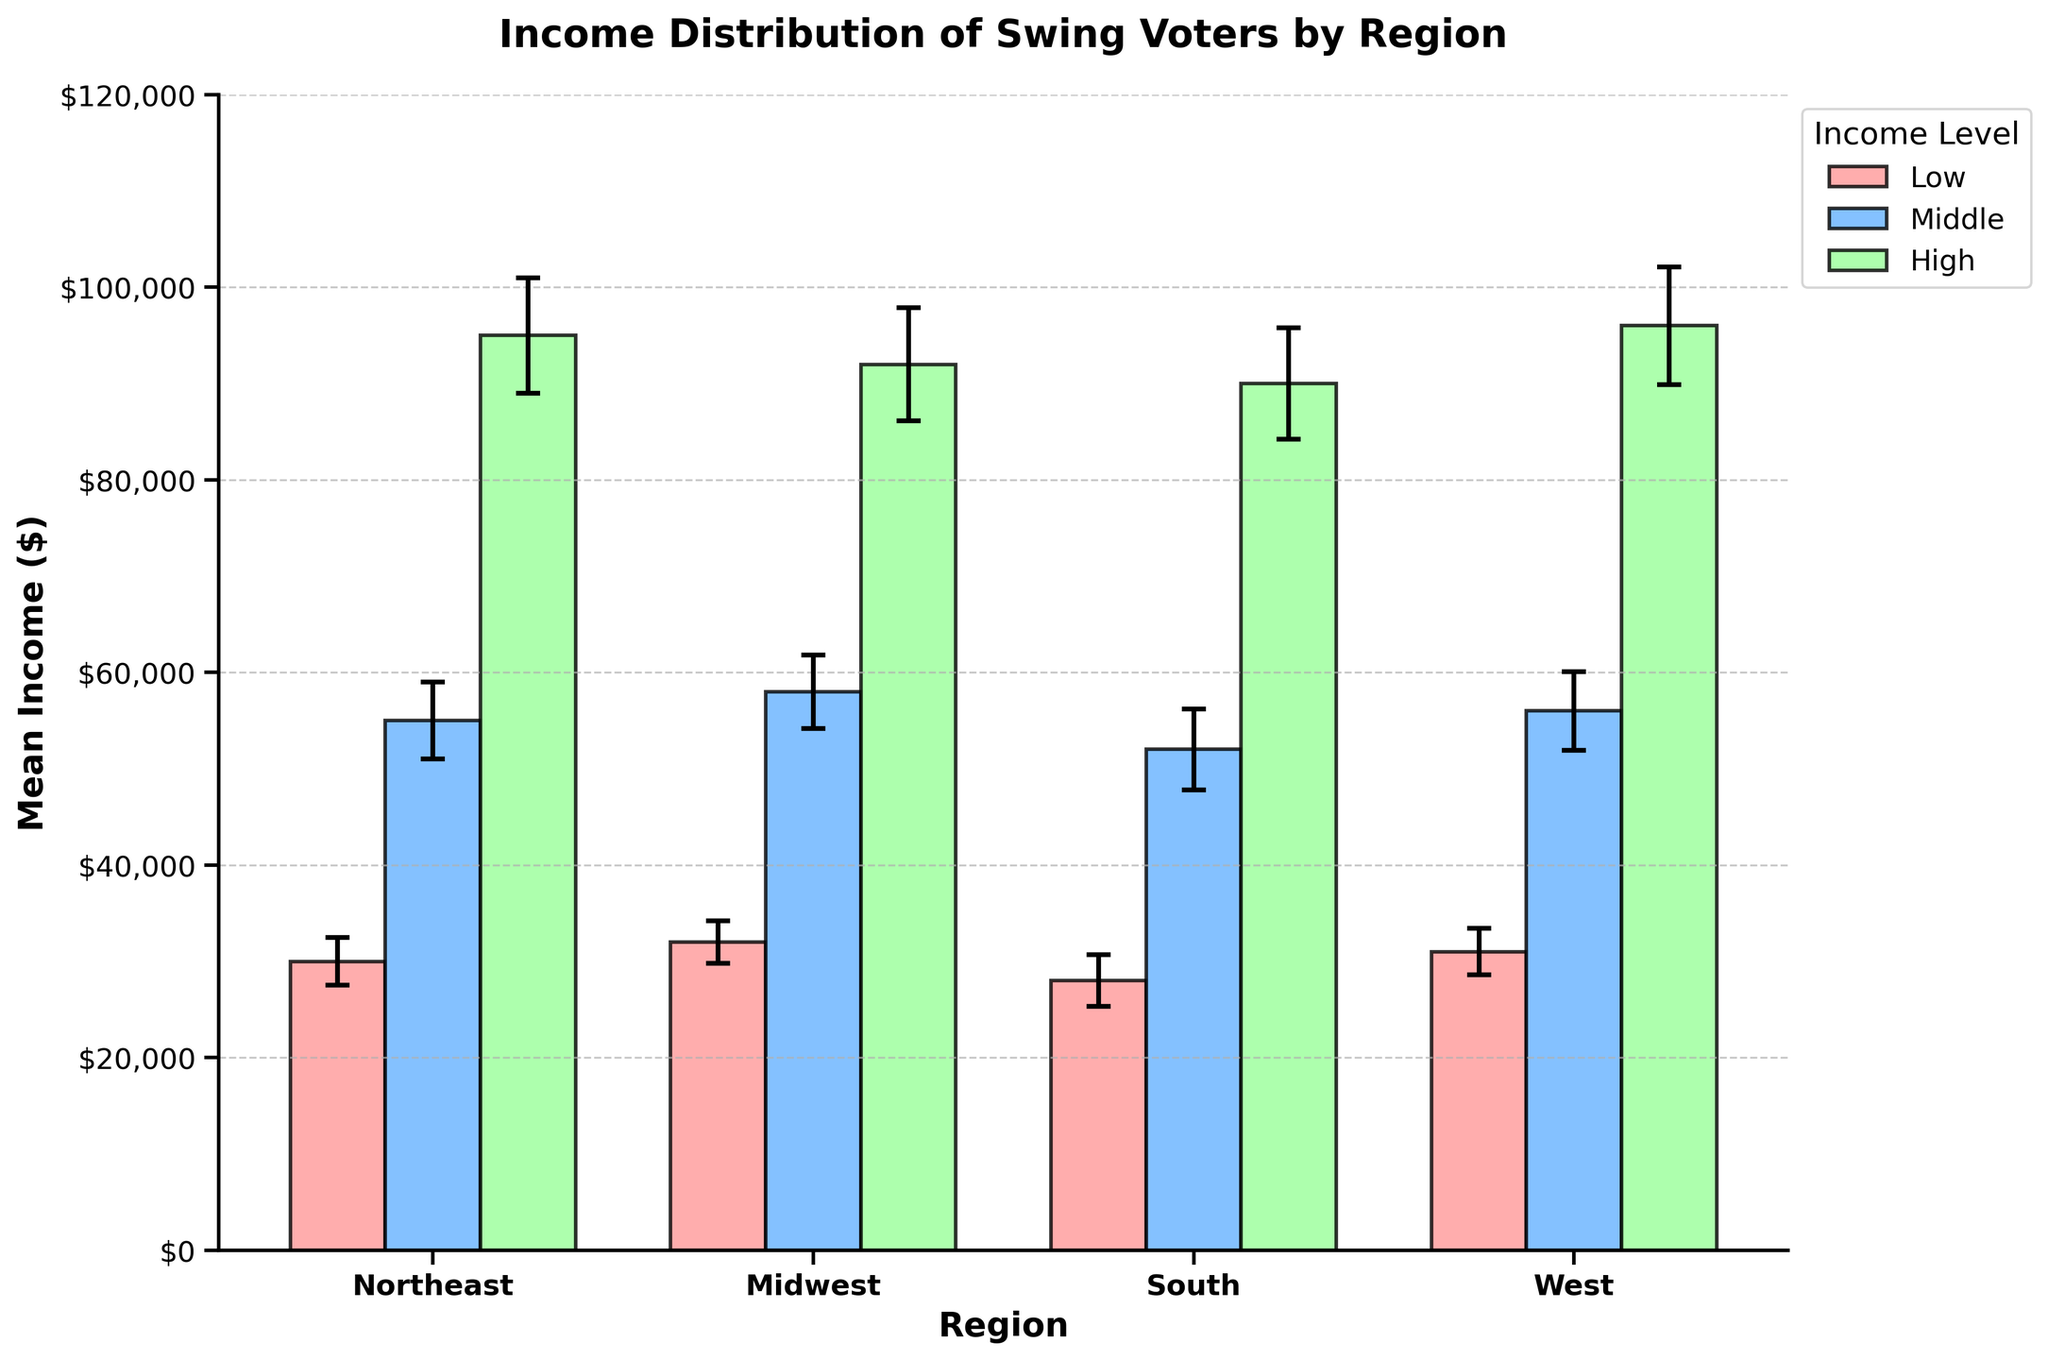what is the mean income for high-income level swing voters in the West? The bar for the high-income level in the West region reaches up to 96000 on the y-axis.
Answer: 96000 How do the error margins for middle-income level swing voters compare between the Midwest and the South? The error bar for middle-income level in the Midwest displays an error of 3800, while for the South it shows an error of 4200.
Answer: The South has a larger error margin What is the mean income difference between low and high-income swing voters in the Northeast? The mean income for low-income swing voters in the Northeast is 30000, and for high-income swing voters, it is 95000. The difference is 95000 - 30000 = 65000.
Answer: 65000 Which region has the lowest mean income for middle-income swing voters? By comparing the heights of the bars for middle-income level across all regions, the South has the lowest mean income of 52000.
Answer: South What are the regions with the highest error margins for each income level? For low-income level, the South has the highest error margin of 2700. For the middle-income level, the South has the highest error margin of 4200. For the high-income level, the West has the highest error margin of 6100.
Answer: South (Low), South (Middle), West (High) Based on the chart, which region has the least variability in income across all levels? The Midwest has relatively narrow error margins across all income levels compared to other regions, with 2200 (Low), 3800 (Middle), and 5900 (High).
Answer: Midwest How does the mean income for middle-income swing voters in the Northeast compare to that in the West? The mean income for middle-income swing voters in the Northeast is 55000, while in the West it is 56000. The difference is 56000 - 55000 = 1000.
Answer: The West is higher by 1000 Which income level consistently has the highest mean income across all regions? Observing the high income level bars for each region (Northeast, Midwest, South, and West), the values are consistently the highest within their respective regions.
Answer: High-income level What's the difference between the highest and lowest mean incomes for swing voters across all regions and income levels? The highest mean income is 96000 (West, High) and the lowest mean income is 28000 (South, Low). The difference is 96000 - 28000 = 68000.
Answer: 68000 